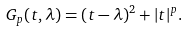<formula> <loc_0><loc_0><loc_500><loc_500>G _ { p } ( t , \lambda ) = ( t - \lambda ) ^ { 2 } + | t | ^ { p } .</formula> 